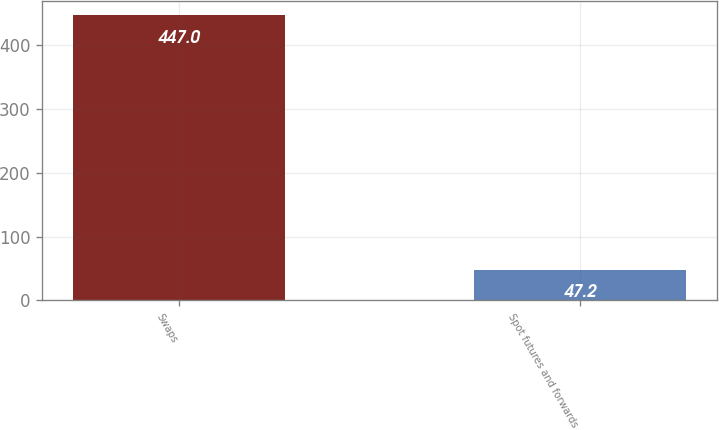<chart> <loc_0><loc_0><loc_500><loc_500><bar_chart><fcel>Swaps<fcel>Spot futures and forwards<nl><fcel>447<fcel>47.2<nl></chart> 